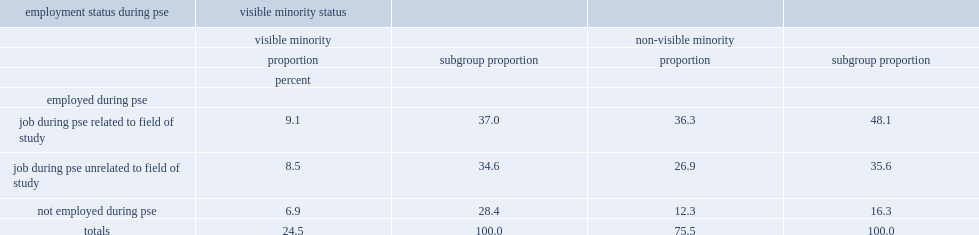What were the percentages of visible and non-visible minorities employed during their pse, respectively? 71.6 83.7. What were the percentages of visible minorities and non-visible minorities who worked in a job related to their field respectively? 37.0 48.1. Who were more likely to have said employment be related to their field,non-visible minorities or visible minorities? Non-visible minority. 